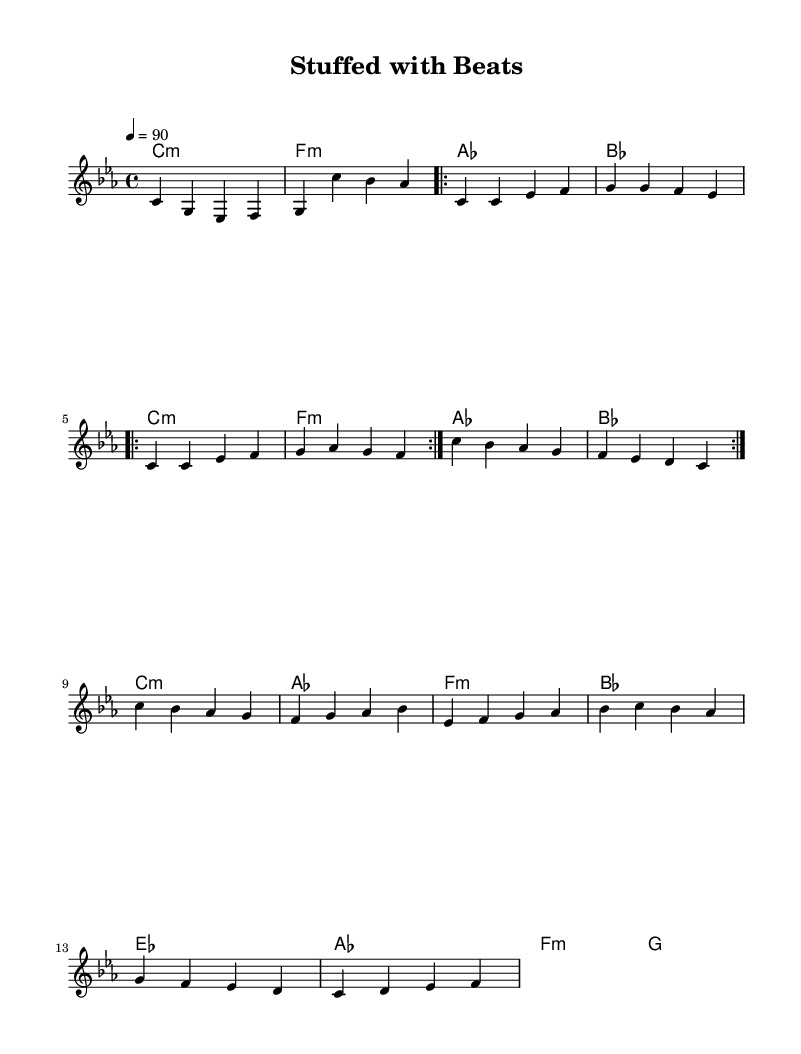What is the key signature of this music? The key signature is indicated at the beginning of the sheet music, where it shows C minor, which has three flats: B flat, E flat, and A flat.
Answer: C minor What is the time signature of this music? The time signature appears next to the key signature and is listed as 4/4, meaning there are four beats in each measure.
Answer: 4/4 What is the tempo marking for this piece? The tempo marking is located in the tempo section, showing "4 = 90," which instructs the performer to play at a speed of 90 beats per minute.
Answer: 90 How many verses are repeated in the music? In the verse section, the notation indicates a repeat sign, which suggests the verse is intended to be played twice, as marked by the repeat volta.
Answer: 2 What type of musical style is this piece classified under? The title of the piece, along with the thematic elements discussed, clearly indicates that it falls under the experimental hip-hop genre, particularly given its exploration of life and death through taxidermy metaphors.
Answer: Experimental hip-hop Which chord is played during the bridge section? Observing the chord mode section, the chords played in the bridge include E flat, A flat, F minor, and G, indicating a movement through various harmonies.
Answer: E flat What is the last note of the melody? By analyzing the melody section, the last note in the final measure is F, which can be identified in the specific placement on the staff.
Answer: F 